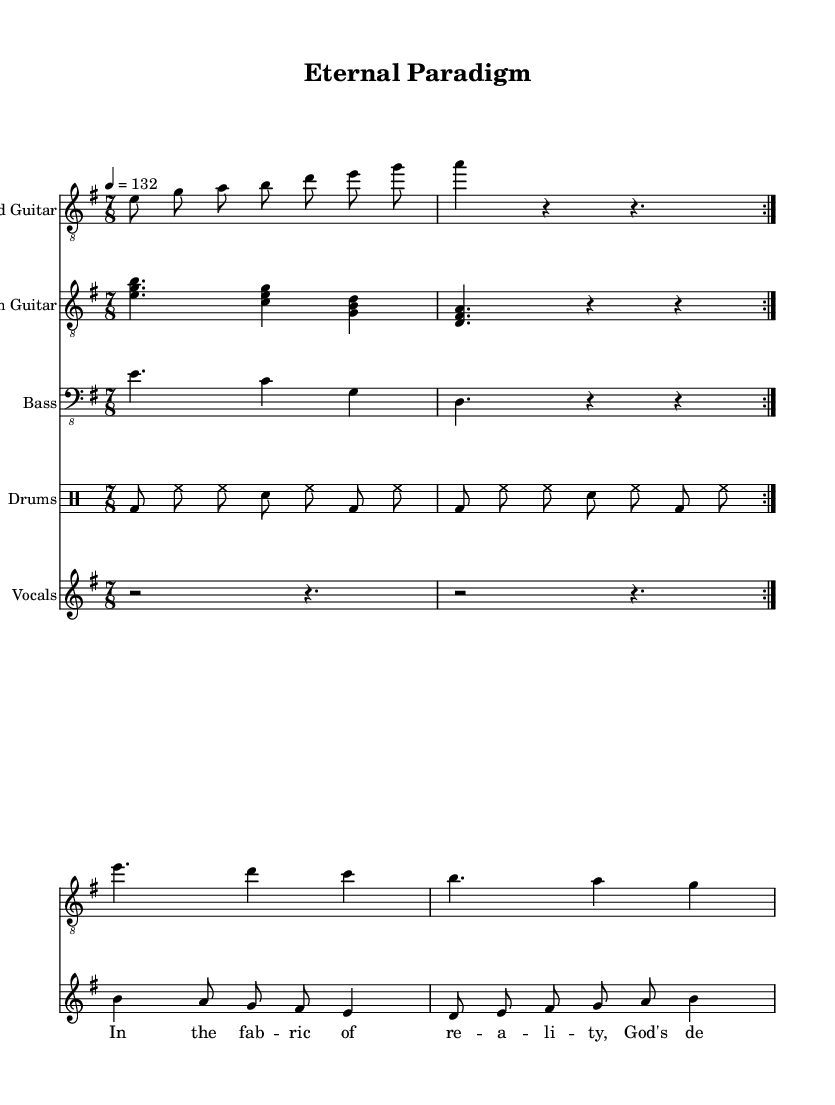What is the key signature of this music? The key signature is indicated at the beginning of the staff, showing one sharp (F#), which corresponds to E minor.
Answer: E minor What is the time signature of this music? The time signature is shown at the beginning of the score as 7/8, indicating there are seven beats in each measure, with the eighth note receiving one beat.
Answer: 7/8 What is the tempo of the piece? The tempo marking indicates a speed of 132 beats per minute, specifically set as a quarter note (4) equals 132.
Answer: 132 How many measures are in the guitar lead section? By examining the guitar lead, we count the repeated volta (double repetition) consisting of 2 measures from the main riff, followed by an additional 3 measures, totaling 5 measures.
Answer: 5 What is the role of the drums in this composition? The drums maintain a steady beat throughout the piece, playing a combination of bass drum (bd), hi-hat (hh), and snare (sn), typical in progressive metal for driving rhythm.
Answer: Driving rhythm What themes are reflected in the lyrics of the chorus? The lyrics speak of "the fabric of reality" and "God's design," indicating a fusion of philosophical and Christian themes, implying a reflection on existence through a divine lens.
Answer: Christian themes What type of structure is used for the chorus section? The chorus utilizes a melodic contour, contrasting with the verses, and features a lyrical structure that complements the philosophical exploration of reality, typical of progressive metal.
Answer: Melodic contour 